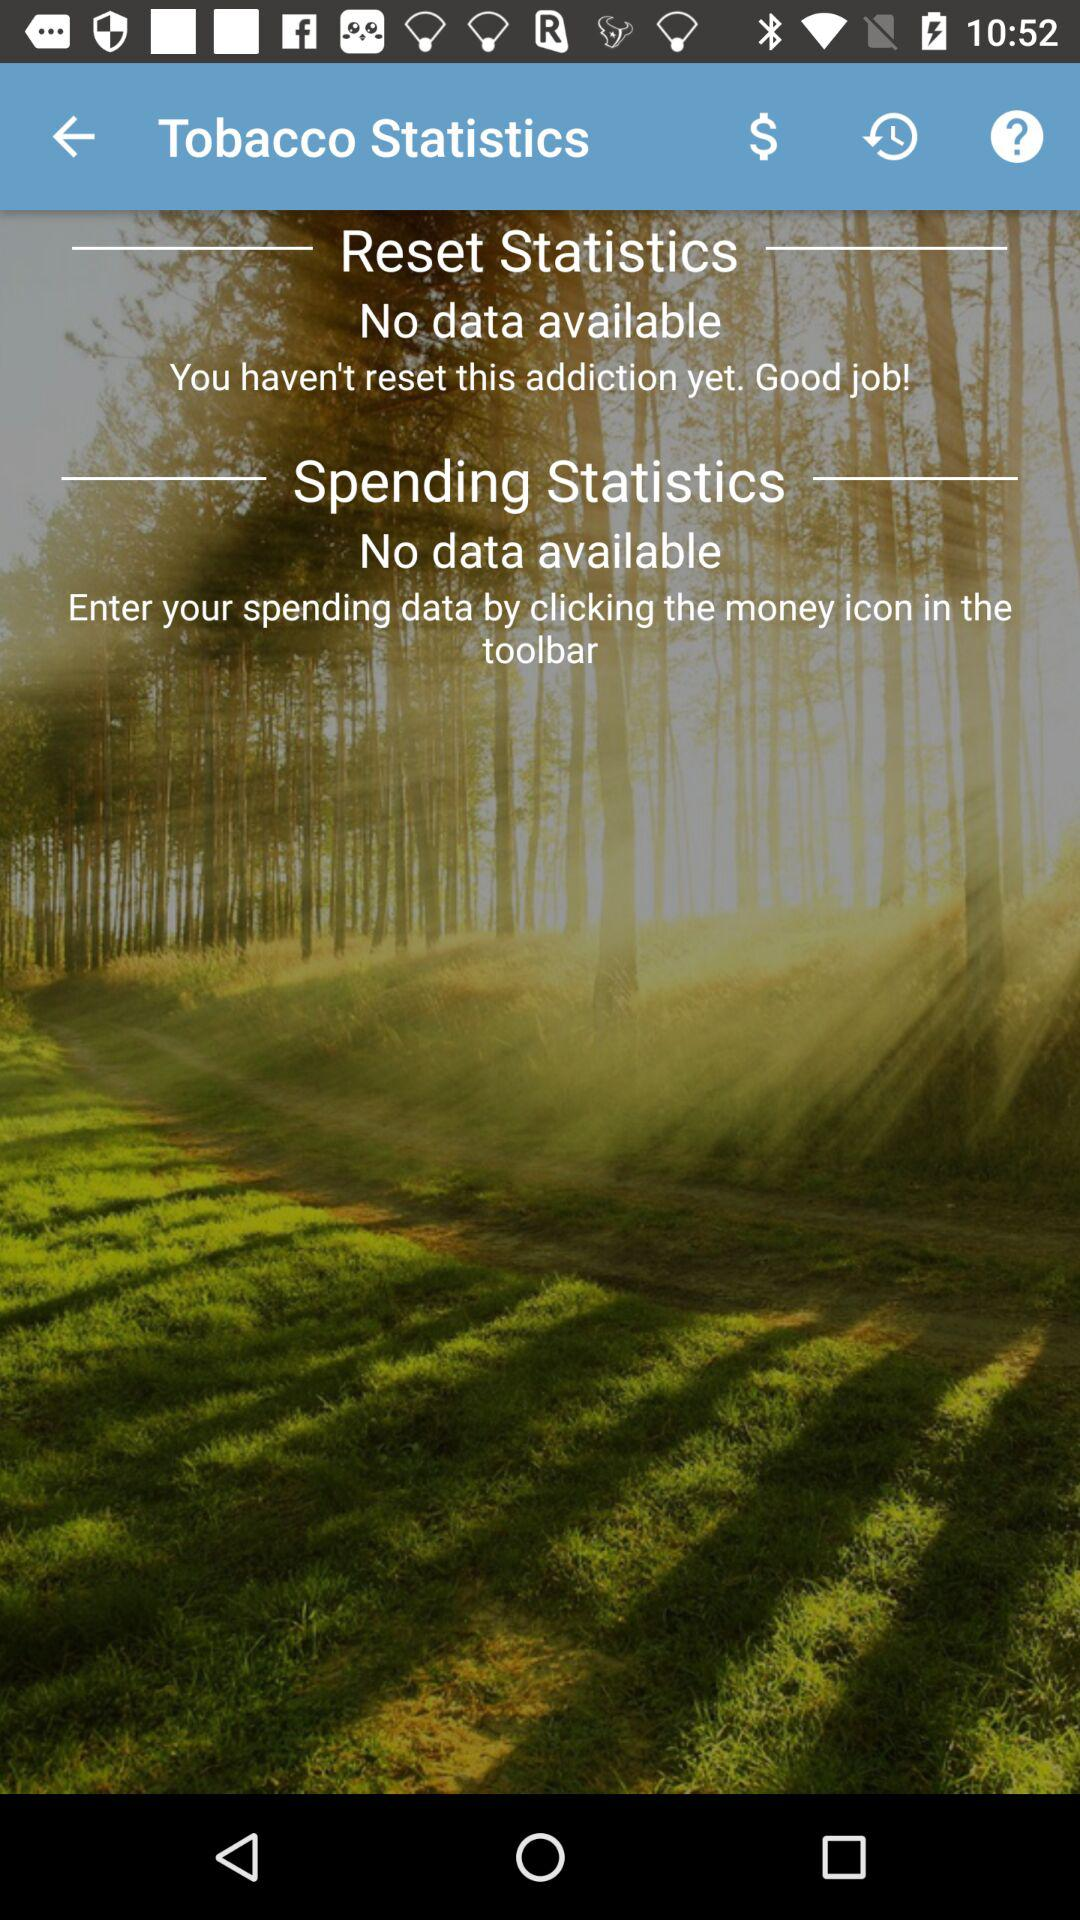Is there any data on reset statistics? There is no data available. 